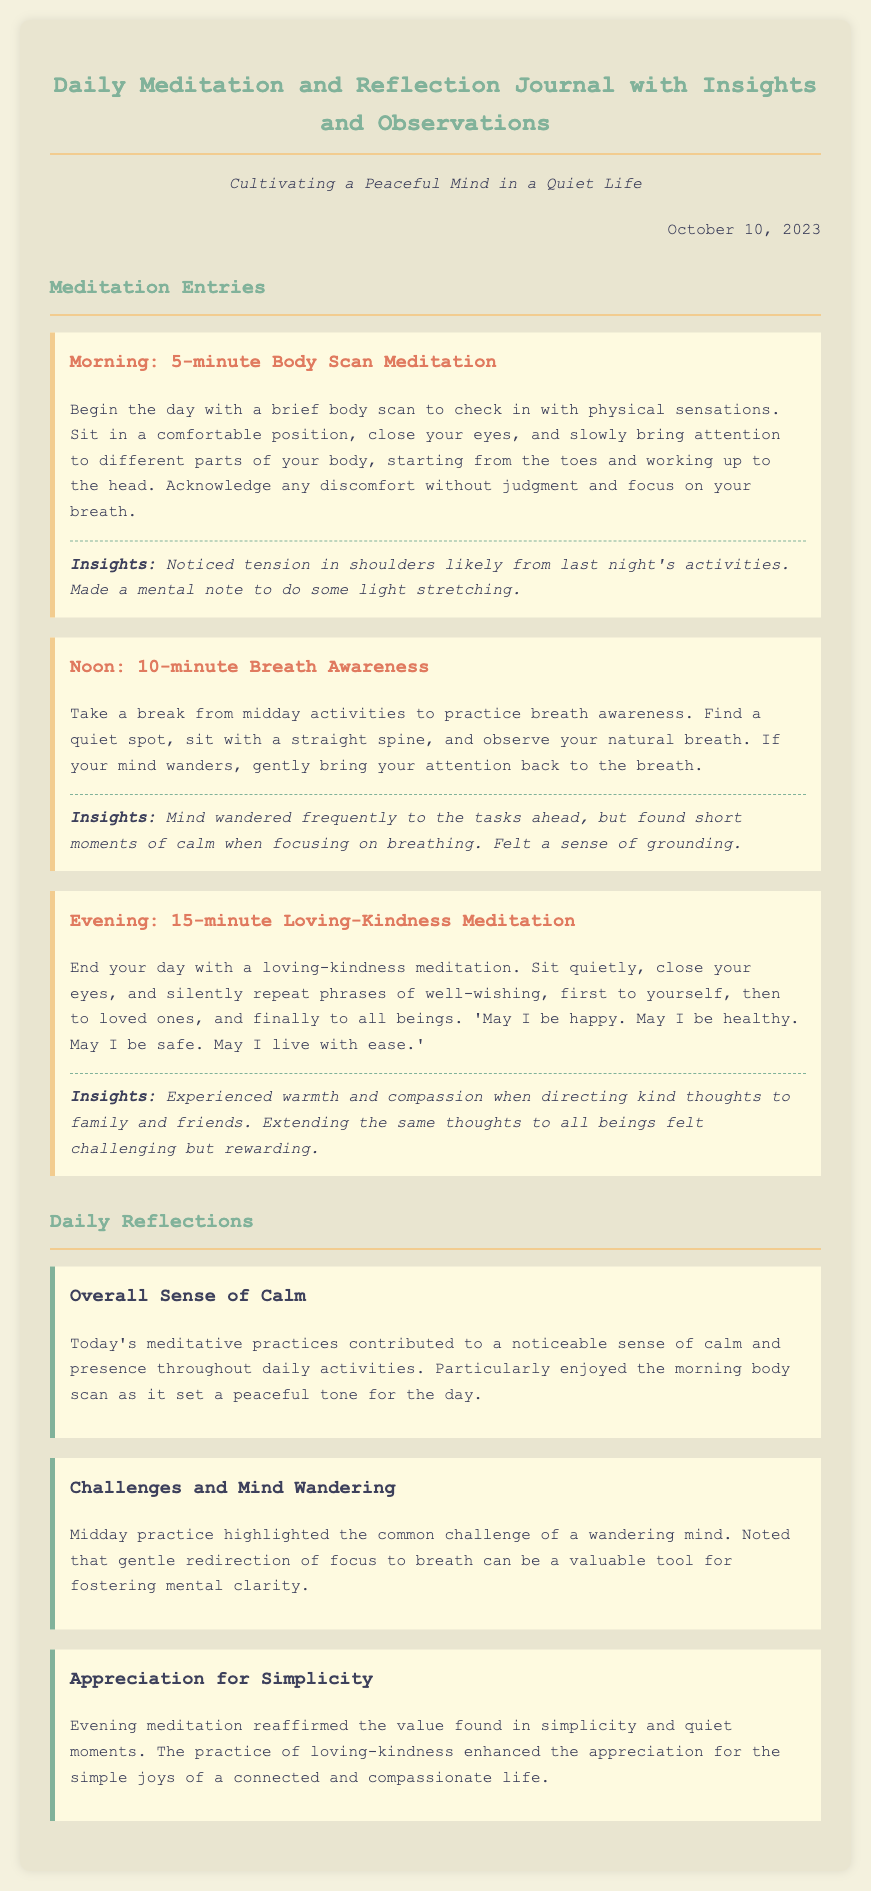what date is the journal entry from? The journal entry is dated October 10, 2023.
Answer: October 10, 2023 how long is the noon meditation practice? The noon meditation practice is described as being 10 minutes long.
Answer: 10 minutes what is the focus of the morning meditation? The morning meditation focuses on a body scan to check in with physical sensations.
Answer: body scan which meditation practice involves repeating well-wishing phrases? The evening meditation involves repeating phrases of loving-kindness.
Answer: loving-kindness meditation what was noted as a common challenge during the midday practice? The common challenge noted was a wandering mind.
Answer: wandering mind how did the morning body scan affect the day's tone? The morning body scan set a peaceful tone for the day.
Answer: peaceful tone what emotion was experienced during the evening loving-kindness meditation? Warmth and compassion were the emotions experienced during this meditation.
Answer: warmth and compassion what does the reflection on simplicity emphasize? The reflection on simplicity emphasizes appreciation for simple joys.
Answer: appreciation for simplicity 